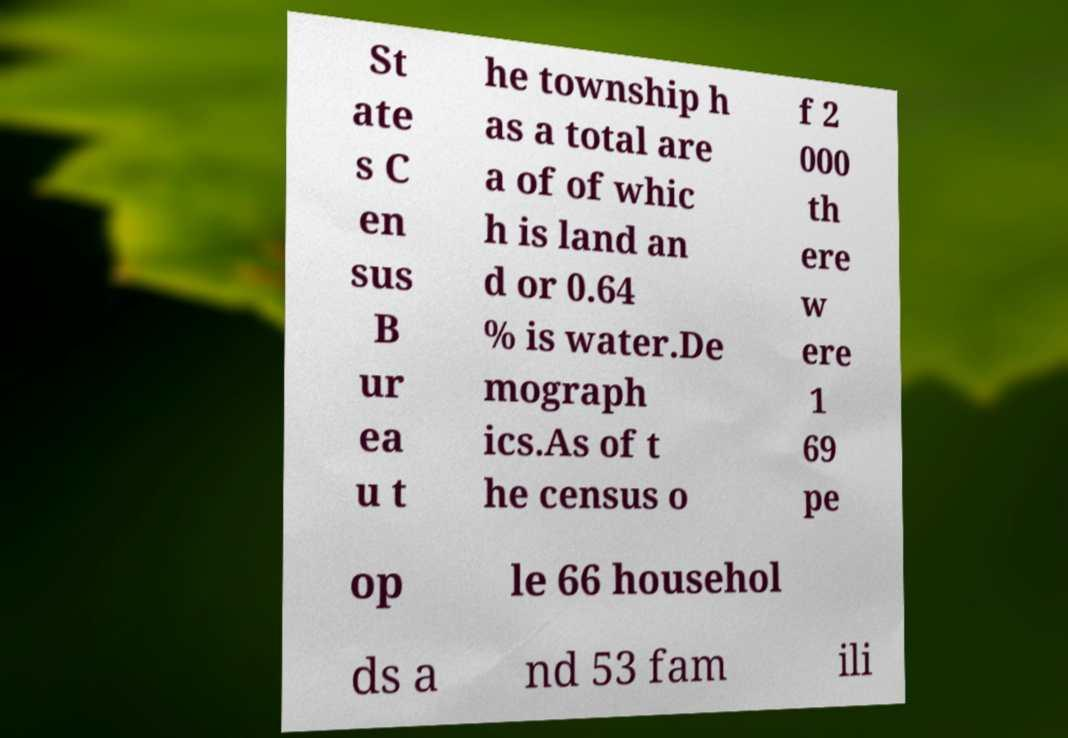I need the written content from this picture converted into text. Can you do that? St ate s C en sus B ur ea u t he township h as a total are a of of whic h is land an d or 0.64 % is water.De mograph ics.As of t he census o f 2 000 th ere w ere 1 69 pe op le 66 househol ds a nd 53 fam ili 